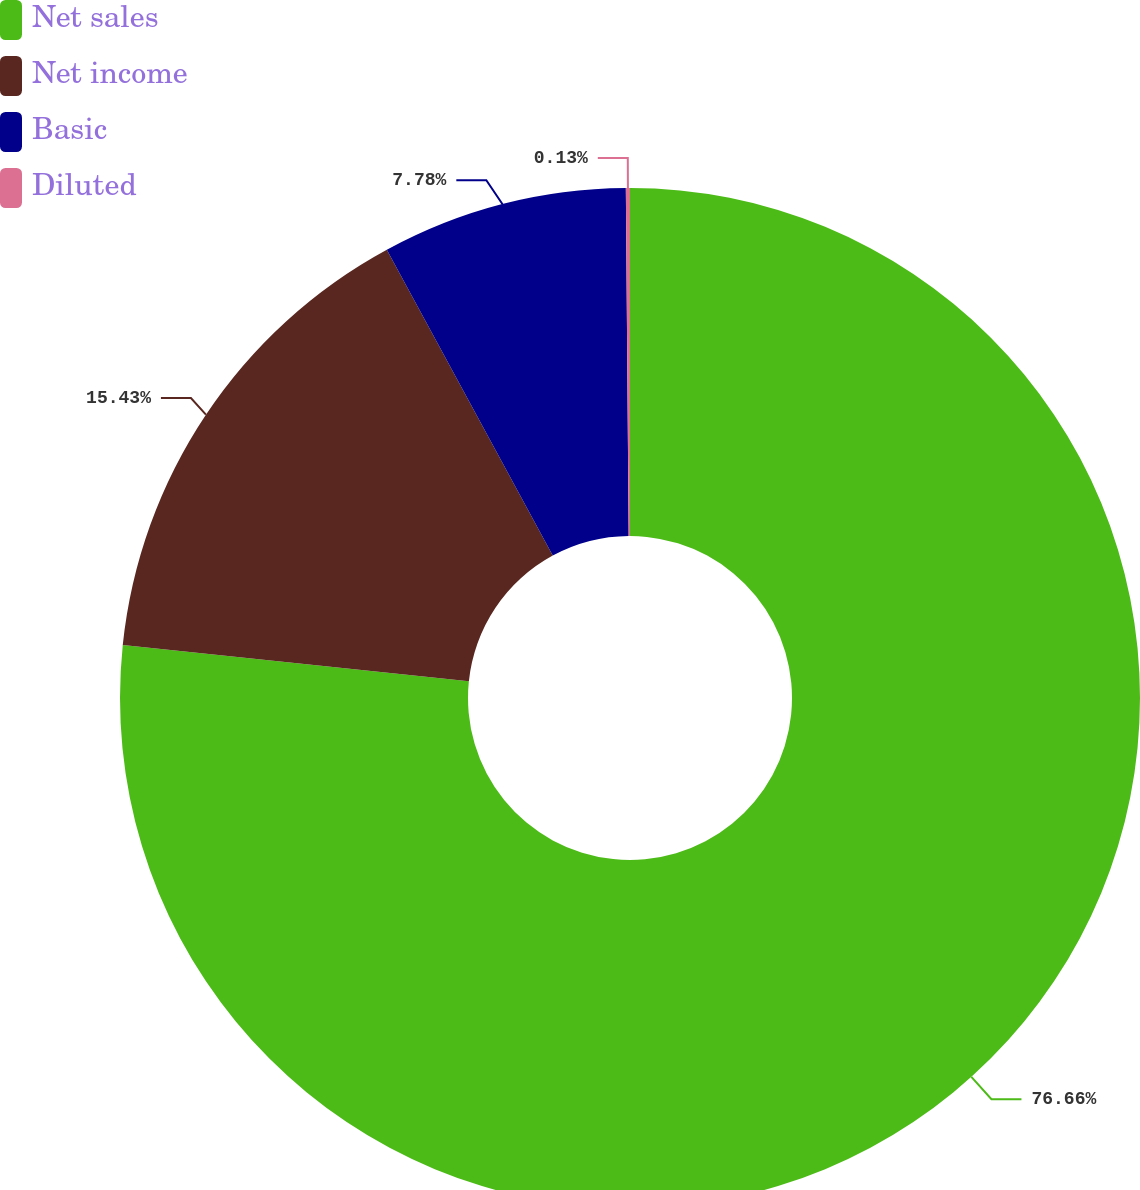Convert chart to OTSL. <chart><loc_0><loc_0><loc_500><loc_500><pie_chart><fcel>Net sales<fcel>Net income<fcel>Basic<fcel>Diluted<nl><fcel>76.65%<fcel>15.43%<fcel>7.78%<fcel>0.13%<nl></chart> 